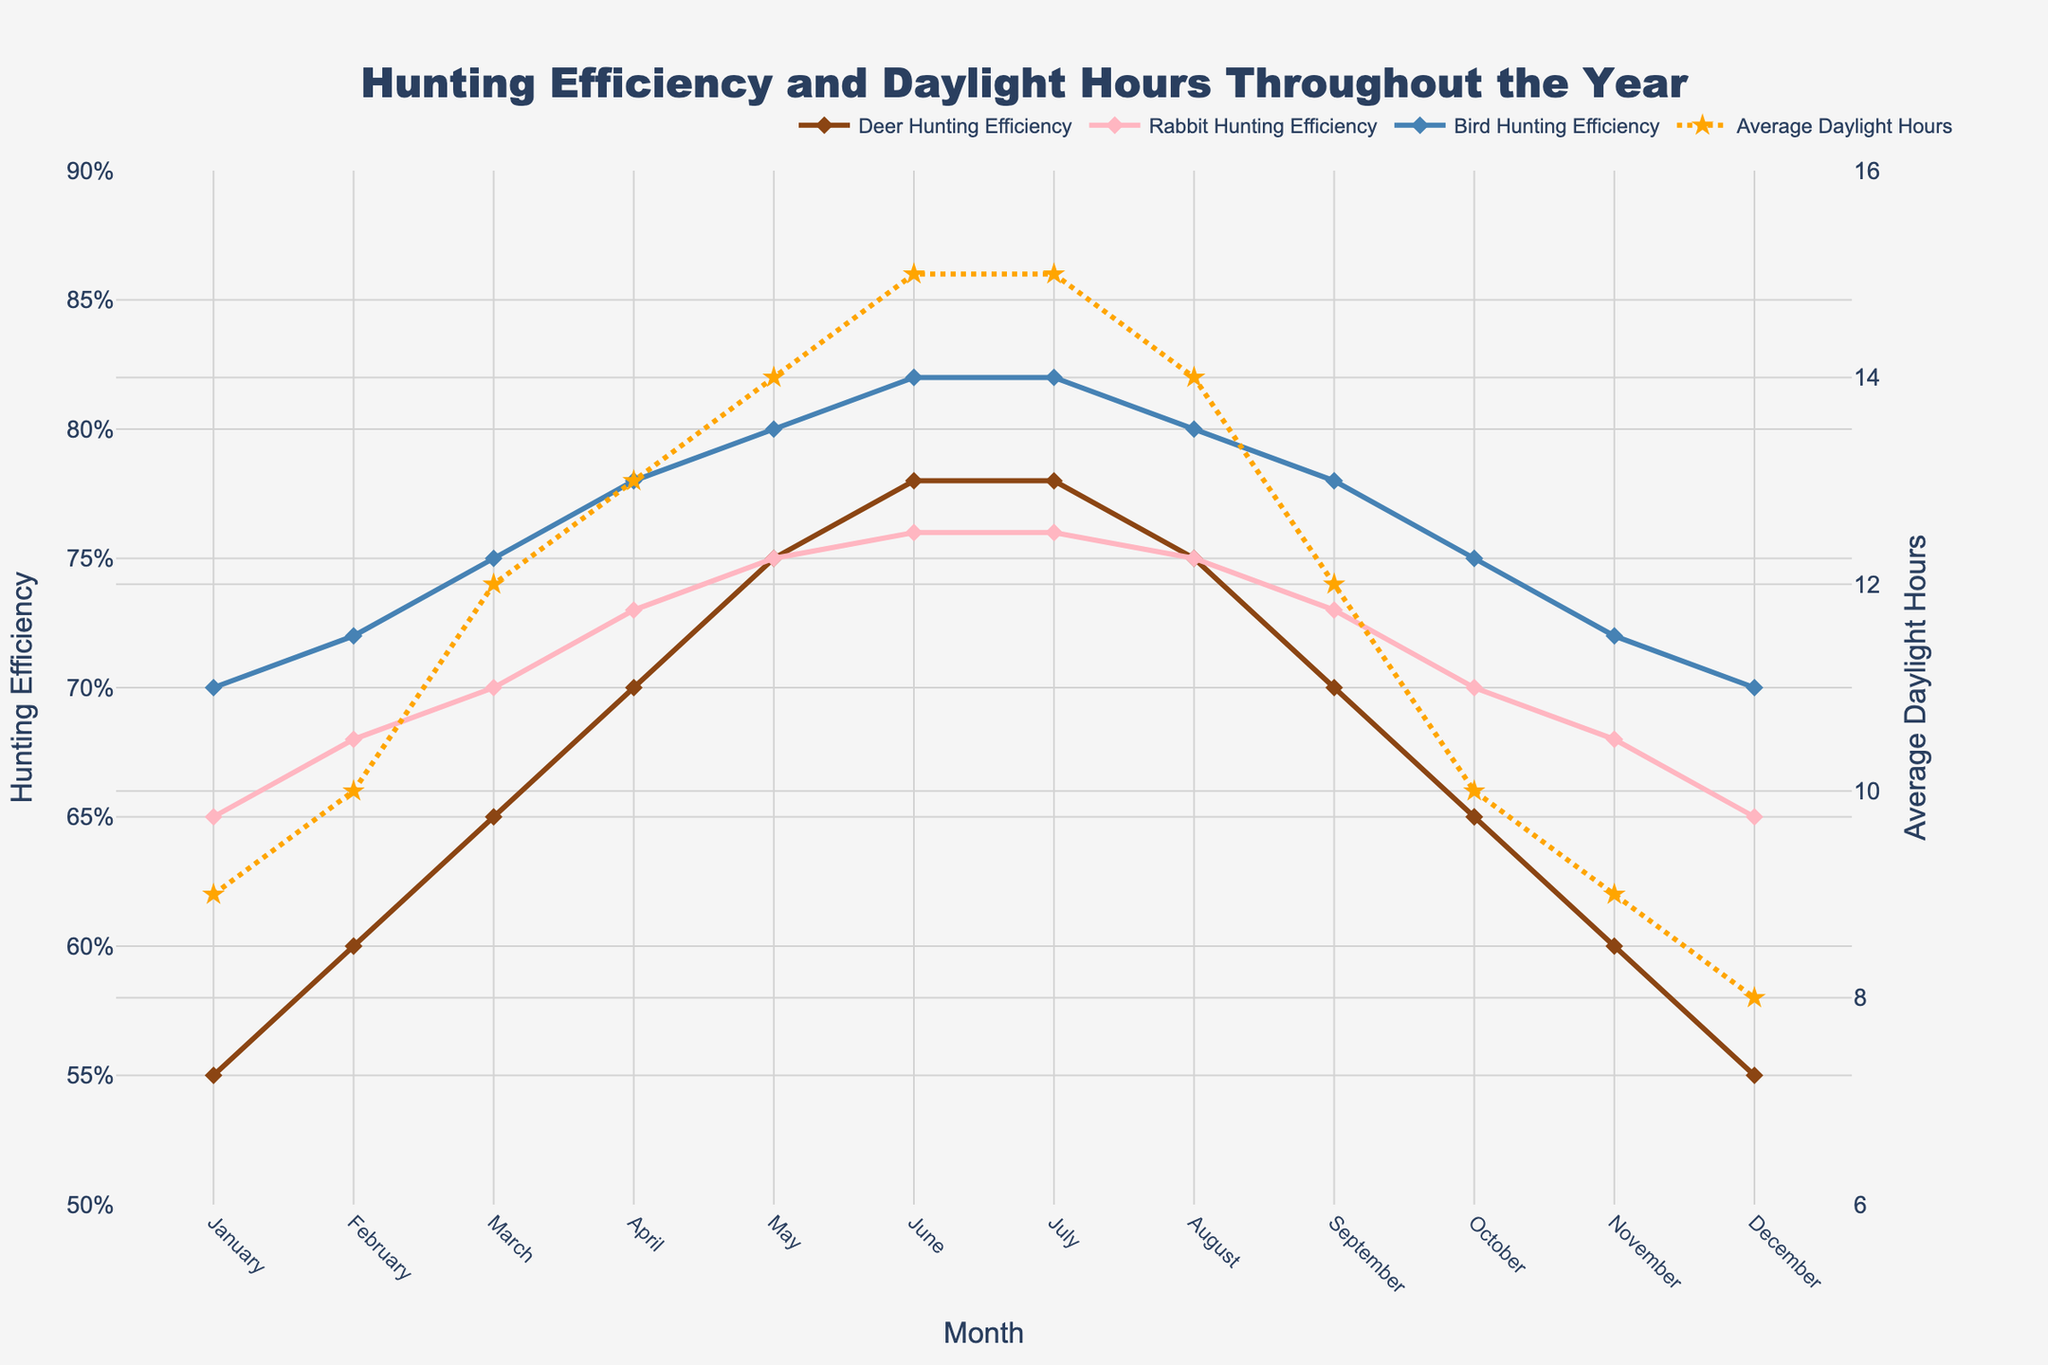What's the title of the figure? The title is prominently displayed at the top of the figure.
Answer: Hunting Efficiency and Daylight Hours Throughout the Year How does the hunting efficiency for Deer in June compare with that in December? Check the data points for Deer in June and December. June is 0.78, and December is 0.55.
Answer: Higher in June Which month has the maximum average daylight hours? The scatter plot with star markers shows the highest point on the dot-dashed line corresponding to June and July.
Answer: June and July How does Rabbit hunting efficiency change from May to June? Observe the markers for Rabbit hunting efficiency from May (0.75) to June (0.76).
Answer: Increases slightly By how much does Bird hunting efficiency increase from March to April? Subtract the Bird hunting efficiency in March (0.75) from that in April (0.78).
Answer: 0.03 What is the average hunting efficiency for Deer across the year? Add up all monthly efficiencies for Deer and divide by 12. (0.55 + 0.60 + 0.65 + 0.70 + 0.75 + 0.78 + 0.78 + 0.75 + 0.70 + 0.65 + 0.60 + 0.55) / 12
Answer: 0.682 Which animal shows the least variance in hunting efficiency throughout the year? Compare the range of efficiency values for Deer (0.55-0.78), Rabbit (0.65-0.76), and Bird (0.70-0.82).
Answer: Rabbit How does daylight hours correlate with Bird hunting efficiency? Observing the trends, as daylight increases, Bird hunting efficiency generally increases.
Answer: Positive correlation In which months do Deer hunting efficiency and daylight hours peak simultaneously? Both metrics peak in June and July.
Answer: June and July Which month shows the largest increase in daylight hours compared to the previous month? Identify month-to-month changes in the dashed line representing daylight hours. The largest increase is from February (10 hours) to March (12 hours).
Answer: March 